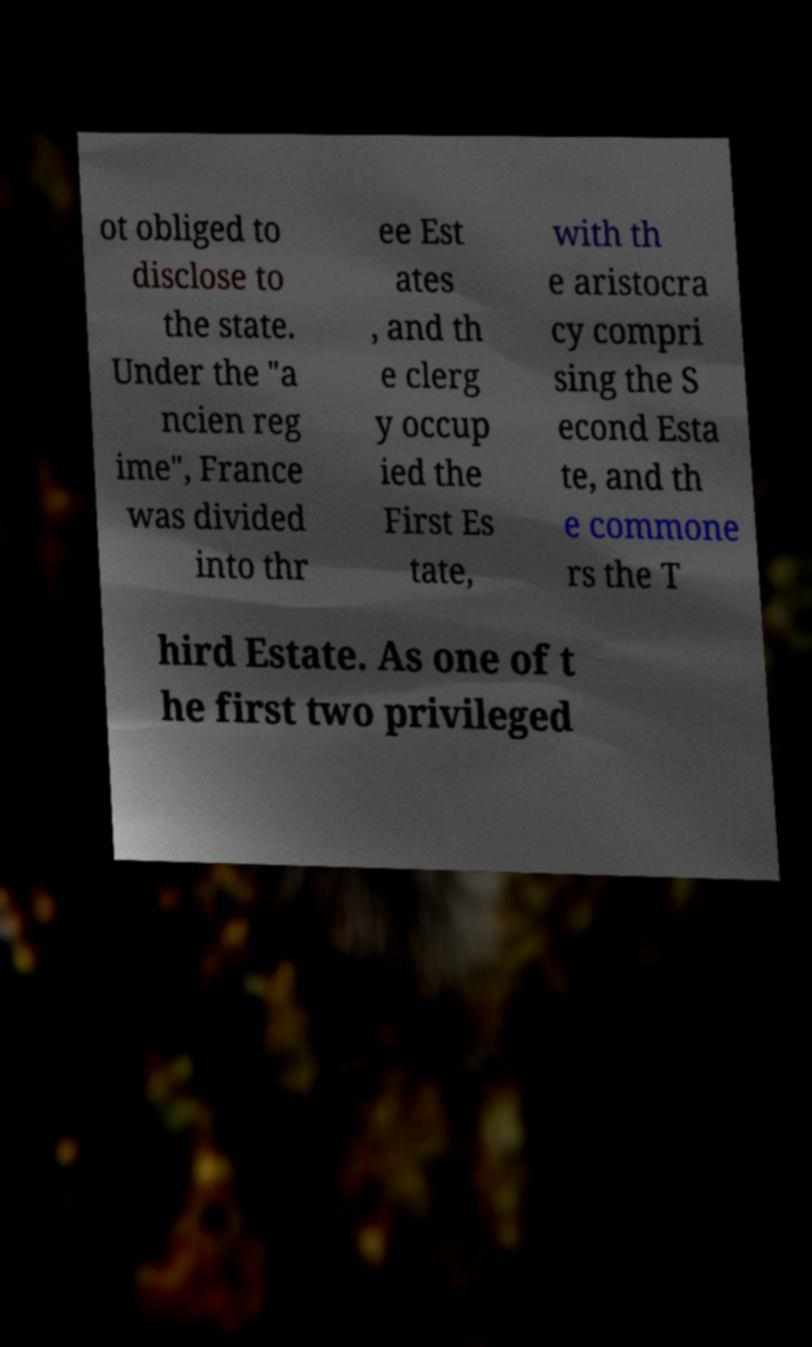Could you extract and type out the text from this image? ot obliged to disclose to the state. Under the "a ncien reg ime", France was divided into thr ee Est ates , and th e clerg y occup ied the First Es tate, with th e aristocra cy compri sing the S econd Esta te, and th e commone rs the T hird Estate. As one of t he first two privileged 